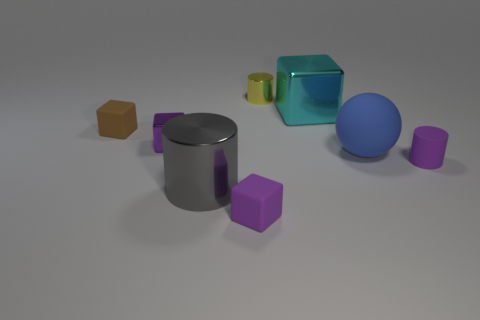What is the size of the metallic block that is the same color as the rubber cylinder?
Give a very brief answer. Small. Does the big cube have the same color as the matte sphere?
Offer a terse response. No. What number of tiny purple rubber cylinders are there?
Offer a terse response. 1. Are there fewer small yellow objects on the left side of the purple shiny block than yellow cylinders?
Offer a very short reply. Yes. Is the material of the small purple object that is behind the large blue sphere the same as the gray cylinder?
Provide a succinct answer. Yes. The tiny rubber object that is behind the tiny rubber object right of the yellow metallic cylinder that is on the left side of the matte cylinder is what shape?
Provide a succinct answer. Cube. Is there a metallic block that has the same size as the purple shiny object?
Ensure brevity in your answer.  No. How big is the purple matte block?
Offer a terse response. Small. How many other blue matte balls have the same size as the blue sphere?
Ensure brevity in your answer.  0. Are there fewer blue rubber things to the right of the ball than big rubber objects behind the tiny purple cylinder?
Provide a short and direct response. Yes. 